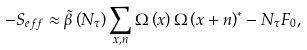Convert formula to latex. <formula><loc_0><loc_0><loc_500><loc_500>- S _ { e f f } \approx \tilde { \beta } \left ( N _ { \tau } \right ) \sum _ { x , n } \Omega \left ( x \right ) \Omega \left ( x + n \right ) ^ { * } - N _ { \tau } F _ { 0 } ,</formula> 